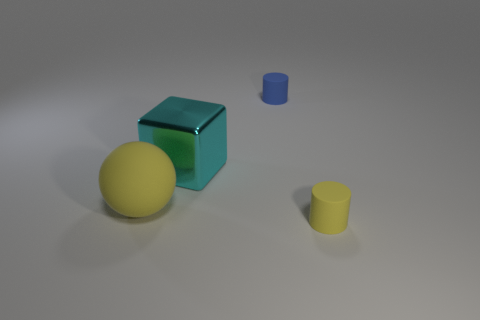What is the color of the small cylinder that is to the left of the small yellow matte object?
Your answer should be compact. Blue. What is the shape of the small rubber thing on the left side of the small matte cylinder in front of the big cyan metal block?
Provide a short and direct response. Cylinder. Is the color of the metallic block the same as the big sphere?
Your response must be concise. No. How many spheres are large cyan shiny objects or yellow rubber things?
Give a very brief answer. 1. What material is the object that is both in front of the small blue thing and behind the big rubber thing?
Your response must be concise. Metal. How many rubber things are behind the big yellow rubber ball?
Make the answer very short. 1. Is the tiny cylinder that is behind the yellow rubber sphere made of the same material as the yellow thing that is left of the cube?
Give a very brief answer. Yes. How many things are either matte cylinders that are in front of the cyan shiny cube or gray shiny spheres?
Ensure brevity in your answer.  1. Are there fewer large yellow objects that are on the right side of the tiny yellow thing than cubes that are behind the large metal block?
Ensure brevity in your answer.  No. Does the cyan block have the same material as the tiny cylinder that is behind the yellow cylinder?
Make the answer very short. No. 